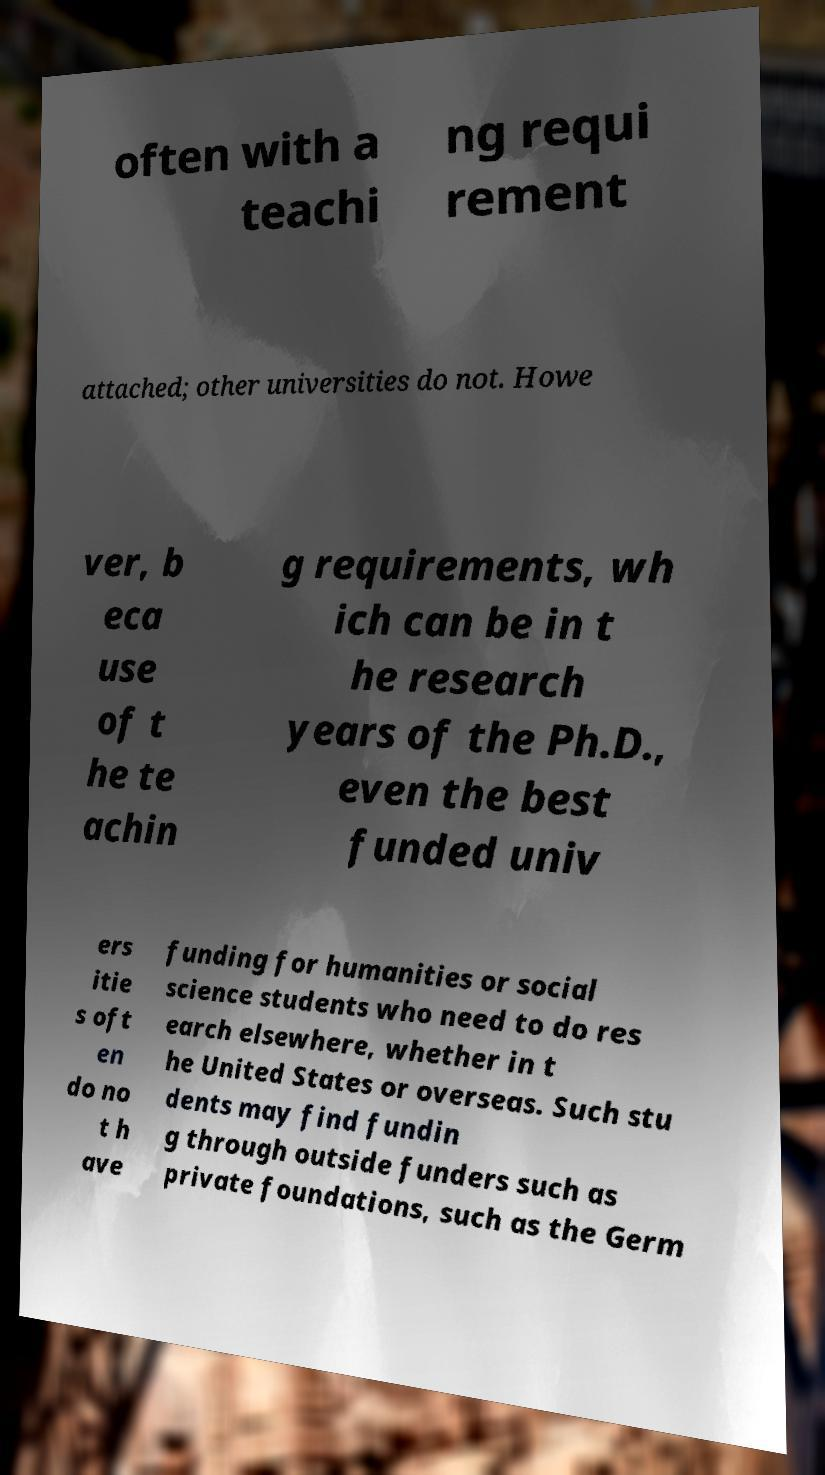Could you extract and type out the text from this image? often with a teachi ng requi rement attached; other universities do not. Howe ver, b eca use of t he te achin g requirements, wh ich can be in t he research years of the Ph.D., even the best funded univ ers itie s oft en do no t h ave funding for humanities or social science students who need to do res earch elsewhere, whether in t he United States or overseas. Such stu dents may find fundin g through outside funders such as private foundations, such as the Germ 